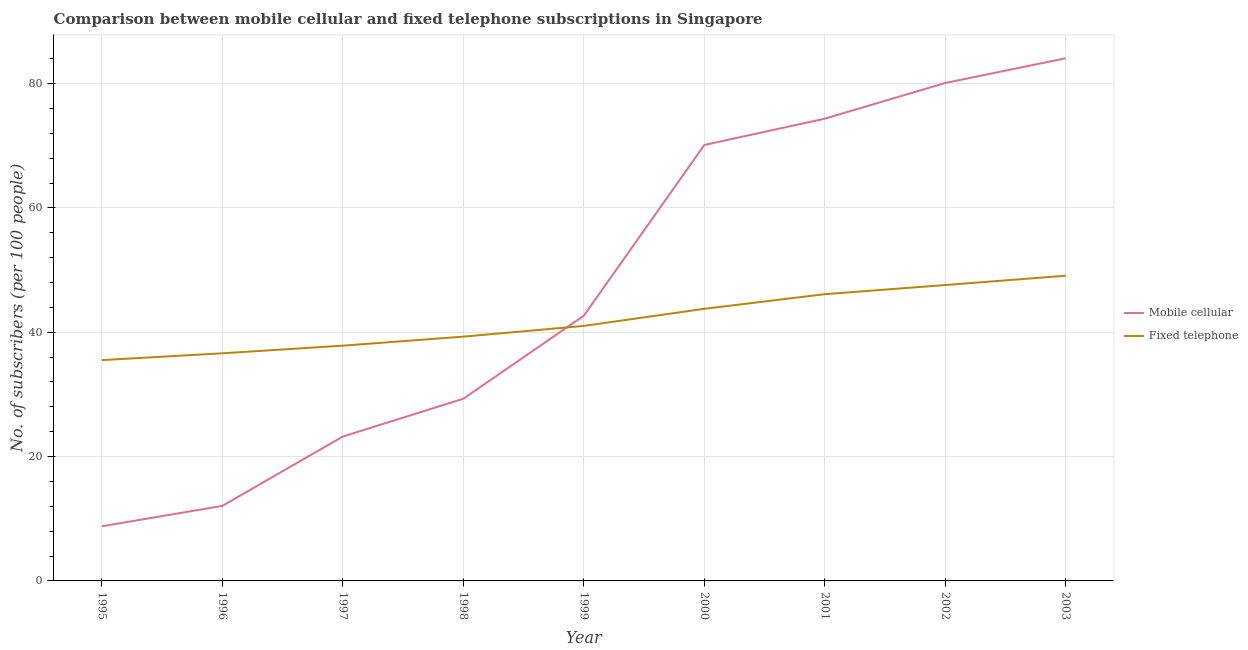How many different coloured lines are there?
Give a very brief answer. 2. Does the line corresponding to number of fixed telephone subscribers intersect with the line corresponding to number of mobile cellular subscribers?
Give a very brief answer. Yes. Is the number of lines equal to the number of legend labels?
Keep it short and to the point. Yes. What is the number of fixed telephone subscribers in 2001?
Offer a terse response. 46.12. Across all years, what is the maximum number of mobile cellular subscribers?
Keep it short and to the point. 84.07. Across all years, what is the minimum number of mobile cellular subscribers?
Your answer should be very brief. 8.79. In which year was the number of fixed telephone subscribers minimum?
Ensure brevity in your answer.  1995. What is the total number of mobile cellular subscribers in the graph?
Your answer should be very brief. 424.7. What is the difference between the number of fixed telephone subscribers in 1995 and that in 1999?
Give a very brief answer. -5.5. What is the difference between the number of mobile cellular subscribers in 2001 and the number of fixed telephone subscribers in 1995?
Make the answer very short. 38.84. What is the average number of fixed telephone subscribers per year?
Provide a short and direct response. 41.87. In the year 2000, what is the difference between the number of fixed telephone subscribers and number of mobile cellular subscribers?
Provide a short and direct response. -26.35. What is the ratio of the number of fixed telephone subscribers in 1996 to that in 2003?
Your response must be concise. 0.75. Is the number of fixed telephone subscribers in 1999 less than that in 2000?
Provide a short and direct response. Yes. What is the difference between the highest and the second highest number of mobile cellular subscribers?
Keep it short and to the point. 3.97. What is the difference between the highest and the lowest number of mobile cellular subscribers?
Offer a terse response. 75.28. In how many years, is the number of fixed telephone subscribers greater than the average number of fixed telephone subscribers taken over all years?
Make the answer very short. 4. Does the number of mobile cellular subscribers monotonically increase over the years?
Provide a succinct answer. Yes. Is the number of fixed telephone subscribers strictly greater than the number of mobile cellular subscribers over the years?
Your response must be concise. No. How many years are there in the graph?
Offer a very short reply. 9. What is the difference between two consecutive major ticks on the Y-axis?
Your response must be concise. 20. Does the graph contain any zero values?
Keep it short and to the point. No. How many legend labels are there?
Your answer should be very brief. 2. What is the title of the graph?
Your answer should be compact. Comparison between mobile cellular and fixed telephone subscriptions in Singapore. What is the label or title of the Y-axis?
Your response must be concise. No. of subscribers (per 100 people). What is the No. of subscribers (per 100 people) in Mobile cellular in 1995?
Make the answer very short. 8.79. What is the No. of subscribers (per 100 people) of Fixed telephone in 1995?
Your answer should be compact. 35.52. What is the No. of subscribers (per 100 people) in Mobile cellular in 1996?
Ensure brevity in your answer.  12.07. What is the No. of subscribers (per 100 people) of Fixed telephone in 1996?
Offer a terse response. 36.61. What is the No. of subscribers (per 100 people) in Mobile cellular in 1997?
Offer a very short reply. 23.23. What is the No. of subscribers (per 100 people) in Fixed telephone in 1997?
Your answer should be very brief. 37.84. What is the No. of subscribers (per 100 people) of Mobile cellular in 1998?
Offer a very short reply. 29.31. What is the No. of subscribers (per 100 people) of Fixed telephone in 1998?
Your answer should be very brief. 39.29. What is the No. of subscribers (per 100 people) in Mobile cellular in 1999?
Provide a succinct answer. 42.66. What is the No. of subscribers (per 100 people) of Fixed telephone in 1999?
Give a very brief answer. 41.02. What is the No. of subscribers (per 100 people) in Mobile cellular in 2000?
Make the answer very short. 70.12. What is the No. of subscribers (per 100 people) in Fixed telephone in 2000?
Offer a very short reply. 43.77. What is the No. of subscribers (per 100 people) of Mobile cellular in 2001?
Ensure brevity in your answer.  74.36. What is the No. of subscribers (per 100 people) of Fixed telephone in 2001?
Give a very brief answer. 46.12. What is the No. of subscribers (per 100 people) in Mobile cellular in 2002?
Your response must be concise. 80.1. What is the No. of subscribers (per 100 people) in Fixed telephone in 2002?
Your answer should be very brief. 47.59. What is the No. of subscribers (per 100 people) of Mobile cellular in 2003?
Keep it short and to the point. 84.07. What is the No. of subscribers (per 100 people) in Fixed telephone in 2003?
Your response must be concise. 49.09. Across all years, what is the maximum No. of subscribers (per 100 people) of Mobile cellular?
Provide a succinct answer. 84.07. Across all years, what is the maximum No. of subscribers (per 100 people) of Fixed telephone?
Make the answer very short. 49.09. Across all years, what is the minimum No. of subscribers (per 100 people) in Mobile cellular?
Make the answer very short. 8.79. Across all years, what is the minimum No. of subscribers (per 100 people) in Fixed telephone?
Offer a very short reply. 35.52. What is the total No. of subscribers (per 100 people) in Mobile cellular in the graph?
Give a very brief answer. 424.7. What is the total No. of subscribers (per 100 people) in Fixed telephone in the graph?
Your response must be concise. 376.87. What is the difference between the No. of subscribers (per 100 people) in Mobile cellular in 1995 and that in 1996?
Your answer should be compact. -3.29. What is the difference between the No. of subscribers (per 100 people) in Fixed telephone in 1995 and that in 1996?
Your answer should be compact. -1.1. What is the difference between the No. of subscribers (per 100 people) of Mobile cellular in 1995 and that in 1997?
Provide a succinct answer. -14.44. What is the difference between the No. of subscribers (per 100 people) of Fixed telephone in 1995 and that in 1997?
Offer a very short reply. -2.33. What is the difference between the No. of subscribers (per 100 people) of Mobile cellular in 1995 and that in 1998?
Your answer should be very brief. -20.52. What is the difference between the No. of subscribers (per 100 people) in Fixed telephone in 1995 and that in 1998?
Offer a terse response. -3.78. What is the difference between the No. of subscribers (per 100 people) of Mobile cellular in 1995 and that in 1999?
Your answer should be compact. -33.88. What is the difference between the No. of subscribers (per 100 people) of Fixed telephone in 1995 and that in 1999?
Make the answer very short. -5.5. What is the difference between the No. of subscribers (per 100 people) in Mobile cellular in 1995 and that in 2000?
Your response must be concise. -61.33. What is the difference between the No. of subscribers (per 100 people) in Fixed telephone in 1995 and that in 2000?
Provide a short and direct response. -8.25. What is the difference between the No. of subscribers (per 100 people) in Mobile cellular in 1995 and that in 2001?
Provide a succinct answer. -65.57. What is the difference between the No. of subscribers (per 100 people) of Fixed telephone in 1995 and that in 2001?
Your answer should be compact. -10.61. What is the difference between the No. of subscribers (per 100 people) in Mobile cellular in 1995 and that in 2002?
Offer a terse response. -71.31. What is the difference between the No. of subscribers (per 100 people) of Fixed telephone in 1995 and that in 2002?
Your answer should be very brief. -12.08. What is the difference between the No. of subscribers (per 100 people) in Mobile cellular in 1995 and that in 2003?
Provide a short and direct response. -75.28. What is the difference between the No. of subscribers (per 100 people) of Fixed telephone in 1995 and that in 2003?
Provide a short and direct response. -13.57. What is the difference between the No. of subscribers (per 100 people) of Mobile cellular in 1996 and that in 1997?
Make the answer very short. -11.16. What is the difference between the No. of subscribers (per 100 people) in Fixed telephone in 1996 and that in 1997?
Your response must be concise. -1.23. What is the difference between the No. of subscribers (per 100 people) in Mobile cellular in 1996 and that in 1998?
Your answer should be compact. -17.23. What is the difference between the No. of subscribers (per 100 people) of Fixed telephone in 1996 and that in 1998?
Ensure brevity in your answer.  -2.68. What is the difference between the No. of subscribers (per 100 people) of Mobile cellular in 1996 and that in 1999?
Your answer should be very brief. -30.59. What is the difference between the No. of subscribers (per 100 people) of Fixed telephone in 1996 and that in 1999?
Give a very brief answer. -4.41. What is the difference between the No. of subscribers (per 100 people) of Mobile cellular in 1996 and that in 2000?
Provide a succinct answer. -58.05. What is the difference between the No. of subscribers (per 100 people) in Fixed telephone in 1996 and that in 2000?
Your answer should be very brief. -7.16. What is the difference between the No. of subscribers (per 100 people) in Mobile cellular in 1996 and that in 2001?
Give a very brief answer. -62.28. What is the difference between the No. of subscribers (per 100 people) of Fixed telephone in 1996 and that in 2001?
Provide a succinct answer. -9.51. What is the difference between the No. of subscribers (per 100 people) of Mobile cellular in 1996 and that in 2002?
Give a very brief answer. -68.02. What is the difference between the No. of subscribers (per 100 people) of Fixed telephone in 1996 and that in 2002?
Provide a short and direct response. -10.98. What is the difference between the No. of subscribers (per 100 people) in Mobile cellular in 1996 and that in 2003?
Give a very brief answer. -72. What is the difference between the No. of subscribers (per 100 people) in Fixed telephone in 1996 and that in 2003?
Your answer should be compact. -12.48. What is the difference between the No. of subscribers (per 100 people) in Mobile cellular in 1997 and that in 1998?
Provide a short and direct response. -6.08. What is the difference between the No. of subscribers (per 100 people) in Fixed telephone in 1997 and that in 1998?
Make the answer very short. -1.45. What is the difference between the No. of subscribers (per 100 people) of Mobile cellular in 1997 and that in 1999?
Your answer should be compact. -19.43. What is the difference between the No. of subscribers (per 100 people) of Fixed telephone in 1997 and that in 1999?
Provide a succinct answer. -3.18. What is the difference between the No. of subscribers (per 100 people) of Mobile cellular in 1997 and that in 2000?
Give a very brief answer. -46.89. What is the difference between the No. of subscribers (per 100 people) of Fixed telephone in 1997 and that in 2000?
Your answer should be very brief. -5.93. What is the difference between the No. of subscribers (per 100 people) of Mobile cellular in 1997 and that in 2001?
Offer a terse response. -51.13. What is the difference between the No. of subscribers (per 100 people) in Fixed telephone in 1997 and that in 2001?
Offer a very short reply. -8.28. What is the difference between the No. of subscribers (per 100 people) of Mobile cellular in 1997 and that in 2002?
Keep it short and to the point. -56.87. What is the difference between the No. of subscribers (per 100 people) in Fixed telephone in 1997 and that in 2002?
Your answer should be very brief. -9.75. What is the difference between the No. of subscribers (per 100 people) of Mobile cellular in 1997 and that in 2003?
Offer a terse response. -60.84. What is the difference between the No. of subscribers (per 100 people) of Fixed telephone in 1997 and that in 2003?
Offer a very short reply. -11.25. What is the difference between the No. of subscribers (per 100 people) in Mobile cellular in 1998 and that in 1999?
Offer a terse response. -13.36. What is the difference between the No. of subscribers (per 100 people) in Fixed telephone in 1998 and that in 1999?
Provide a short and direct response. -1.73. What is the difference between the No. of subscribers (per 100 people) in Mobile cellular in 1998 and that in 2000?
Your answer should be compact. -40.81. What is the difference between the No. of subscribers (per 100 people) in Fixed telephone in 1998 and that in 2000?
Your answer should be compact. -4.48. What is the difference between the No. of subscribers (per 100 people) of Mobile cellular in 1998 and that in 2001?
Ensure brevity in your answer.  -45.05. What is the difference between the No. of subscribers (per 100 people) of Fixed telephone in 1998 and that in 2001?
Offer a terse response. -6.83. What is the difference between the No. of subscribers (per 100 people) of Mobile cellular in 1998 and that in 2002?
Offer a very short reply. -50.79. What is the difference between the No. of subscribers (per 100 people) of Mobile cellular in 1998 and that in 2003?
Keep it short and to the point. -54.77. What is the difference between the No. of subscribers (per 100 people) in Fixed telephone in 1998 and that in 2003?
Provide a succinct answer. -9.8. What is the difference between the No. of subscribers (per 100 people) of Mobile cellular in 1999 and that in 2000?
Ensure brevity in your answer.  -27.46. What is the difference between the No. of subscribers (per 100 people) in Fixed telephone in 1999 and that in 2000?
Provide a short and direct response. -2.75. What is the difference between the No. of subscribers (per 100 people) in Mobile cellular in 1999 and that in 2001?
Provide a succinct answer. -31.7. What is the difference between the No. of subscribers (per 100 people) of Fixed telephone in 1999 and that in 2001?
Provide a succinct answer. -5.1. What is the difference between the No. of subscribers (per 100 people) in Mobile cellular in 1999 and that in 2002?
Offer a terse response. -37.44. What is the difference between the No. of subscribers (per 100 people) of Fixed telephone in 1999 and that in 2002?
Your answer should be compact. -6.57. What is the difference between the No. of subscribers (per 100 people) in Mobile cellular in 1999 and that in 2003?
Give a very brief answer. -41.41. What is the difference between the No. of subscribers (per 100 people) in Fixed telephone in 1999 and that in 2003?
Make the answer very short. -8.07. What is the difference between the No. of subscribers (per 100 people) of Mobile cellular in 2000 and that in 2001?
Give a very brief answer. -4.24. What is the difference between the No. of subscribers (per 100 people) in Fixed telephone in 2000 and that in 2001?
Your answer should be very brief. -2.35. What is the difference between the No. of subscribers (per 100 people) in Mobile cellular in 2000 and that in 2002?
Provide a short and direct response. -9.98. What is the difference between the No. of subscribers (per 100 people) of Fixed telephone in 2000 and that in 2002?
Make the answer very short. -3.82. What is the difference between the No. of subscribers (per 100 people) of Mobile cellular in 2000 and that in 2003?
Give a very brief answer. -13.95. What is the difference between the No. of subscribers (per 100 people) of Fixed telephone in 2000 and that in 2003?
Your response must be concise. -5.32. What is the difference between the No. of subscribers (per 100 people) of Mobile cellular in 2001 and that in 2002?
Your answer should be very brief. -5.74. What is the difference between the No. of subscribers (per 100 people) of Fixed telephone in 2001 and that in 2002?
Give a very brief answer. -1.47. What is the difference between the No. of subscribers (per 100 people) in Mobile cellular in 2001 and that in 2003?
Your response must be concise. -9.71. What is the difference between the No. of subscribers (per 100 people) in Fixed telephone in 2001 and that in 2003?
Offer a very short reply. -2.97. What is the difference between the No. of subscribers (per 100 people) in Mobile cellular in 2002 and that in 2003?
Offer a terse response. -3.97. What is the difference between the No. of subscribers (per 100 people) of Fixed telephone in 2002 and that in 2003?
Give a very brief answer. -1.5. What is the difference between the No. of subscribers (per 100 people) of Mobile cellular in 1995 and the No. of subscribers (per 100 people) of Fixed telephone in 1996?
Provide a succinct answer. -27.83. What is the difference between the No. of subscribers (per 100 people) of Mobile cellular in 1995 and the No. of subscribers (per 100 people) of Fixed telephone in 1997?
Offer a very short reply. -29.06. What is the difference between the No. of subscribers (per 100 people) of Mobile cellular in 1995 and the No. of subscribers (per 100 people) of Fixed telephone in 1998?
Offer a terse response. -30.51. What is the difference between the No. of subscribers (per 100 people) of Mobile cellular in 1995 and the No. of subscribers (per 100 people) of Fixed telephone in 1999?
Offer a terse response. -32.23. What is the difference between the No. of subscribers (per 100 people) of Mobile cellular in 1995 and the No. of subscribers (per 100 people) of Fixed telephone in 2000?
Your answer should be very brief. -34.99. What is the difference between the No. of subscribers (per 100 people) in Mobile cellular in 1995 and the No. of subscribers (per 100 people) in Fixed telephone in 2001?
Keep it short and to the point. -37.34. What is the difference between the No. of subscribers (per 100 people) in Mobile cellular in 1995 and the No. of subscribers (per 100 people) in Fixed telephone in 2002?
Offer a very short reply. -38.81. What is the difference between the No. of subscribers (per 100 people) of Mobile cellular in 1995 and the No. of subscribers (per 100 people) of Fixed telephone in 2003?
Provide a short and direct response. -40.31. What is the difference between the No. of subscribers (per 100 people) of Mobile cellular in 1996 and the No. of subscribers (per 100 people) of Fixed telephone in 1997?
Your answer should be compact. -25.77. What is the difference between the No. of subscribers (per 100 people) of Mobile cellular in 1996 and the No. of subscribers (per 100 people) of Fixed telephone in 1998?
Your answer should be compact. -27.22. What is the difference between the No. of subscribers (per 100 people) in Mobile cellular in 1996 and the No. of subscribers (per 100 people) in Fixed telephone in 1999?
Give a very brief answer. -28.95. What is the difference between the No. of subscribers (per 100 people) in Mobile cellular in 1996 and the No. of subscribers (per 100 people) in Fixed telephone in 2000?
Your response must be concise. -31.7. What is the difference between the No. of subscribers (per 100 people) of Mobile cellular in 1996 and the No. of subscribers (per 100 people) of Fixed telephone in 2001?
Provide a short and direct response. -34.05. What is the difference between the No. of subscribers (per 100 people) of Mobile cellular in 1996 and the No. of subscribers (per 100 people) of Fixed telephone in 2002?
Make the answer very short. -35.52. What is the difference between the No. of subscribers (per 100 people) in Mobile cellular in 1996 and the No. of subscribers (per 100 people) in Fixed telephone in 2003?
Offer a very short reply. -37.02. What is the difference between the No. of subscribers (per 100 people) of Mobile cellular in 1997 and the No. of subscribers (per 100 people) of Fixed telephone in 1998?
Provide a succinct answer. -16.07. What is the difference between the No. of subscribers (per 100 people) of Mobile cellular in 1997 and the No. of subscribers (per 100 people) of Fixed telephone in 1999?
Give a very brief answer. -17.79. What is the difference between the No. of subscribers (per 100 people) in Mobile cellular in 1997 and the No. of subscribers (per 100 people) in Fixed telephone in 2000?
Make the answer very short. -20.54. What is the difference between the No. of subscribers (per 100 people) in Mobile cellular in 1997 and the No. of subscribers (per 100 people) in Fixed telephone in 2001?
Offer a terse response. -22.89. What is the difference between the No. of subscribers (per 100 people) in Mobile cellular in 1997 and the No. of subscribers (per 100 people) in Fixed telephone in 2002?
Offer a terse response. -24.36. What is the difference between the No. of subscribers (per 100 people) of Mobile cellular in 1997 and the No. of subscribers (per 100 people) of Fixed telephone in 2003?
Make the answer very short. -25.86. What is the difference between the No. of subscribers (per 100 people) in Mobile cellular in 1998 and the No. of subscribers (per 100 people) in Fixed telephone in 1999?
Provide a short and direct response. -11.72. What is the difference between the No. of subscribers (per 100 people) in Mobile cellular in 1998 and the No. of subscribers (per 100 people) in Fixed telephone in 2000?
Provide a short and direct response. -14.47. What is the difference between the No. of subscribers (per 100 people) of Mobile cellular in 1998 and the No. of subscribers (per 100 people) of Fixed telephone in 2001?
Your answer should be very brief. -16.82. What is the difference between the No. of subscribers (per 100 people) of Mobile cellular in 1998 and the No. of subscribers (per 100 people) of Fixed telephone in 2002?
Provide a succinct answer. -18.29. What is the difference between the No. of subscribers (per 100 people) of Mobile cellular in 1998 and the No. of subscribers (per 100 people) of Fixed telephone in 2003?
Ensure brevity in your answer.  -19.79. What is the difference between the No. of subscribers (per 100 people) of Mobile cellular in 1999 and the No. of subscribers (per 100 people) of Fixed telephone in 2000?
Provide a succinct answer. -1.11. What is the difference between the No. of subscribers (per 100 people) in Mobile cellular in 1999 and the No. of subscribers (per 100 people) in Fixed telephone in 2001?
Offer a very short reply. -3.46. What is the difference between the No. of subscribers (per 100 people) of Mobile cellular in 1999 and the No. of subscribers (per 100 people) of Fixed telephone in 2002?
Provide a short and direct response. -4.93. What is the difference between the No. of subscribers (per 100 people) in Mobile cellular in 1999 and the No. of subscribers (per 100 people) in Fixed telephone in 2003?
Your answer should be very brief. -6.43. What is the difference between the No. of subscribers (per 100 people) of Mobile cellular in 2000 and the No. of subscribers (per 100 people) of Fixed telephone in 2001?
Ensure brevity in your answer.  24. What is the difference between the No. of subscribers (per 100 people) in Mobile cellular in 2000 and the No. of subscribers (per 100 people) in Fixed telephone in 2002?
Keep it short and to the point. 22.52. What is the difference between the No. of subscribers (per 100 people) of Mobile cellular in 2000 and the No. of subscribers (per 100 people) of Fixed telephone in 2003?
Ensure brevity in your answer.  21.03. What is the difference between the No. of subscribers (per 100 people) in Mobile cellular in 2001 and the No. of subscribers (per 100 people) in Fixed telephone in 2002?
Make the answer very short. 26.76. What is the difference between the No. of subscribers (per 100 people) of Mobile cellular in 2001 and the No. of subscribers (per 100 people) of Fixed telephone in 2003?
Provide a succinct answer. 25.27. What is the difference between the No. of subscribers (per 100 people) in Mobile cellular in 2002 and the No. of subscribers (per 100 people) in Fixed telephone in 2003?
Your response must be concise. 31. What is the average No. of subscribers (per 100 people) in Mobile cellular per year?
Offer a very short reply. 47.19. What is the average No. of subscribers (per 100 people) of Fixed telephone per year?
Your answer should be compact. 41.87. In the year 1995, what is the difference between the No. of subscribers (per 100 people) in Mobile cellular and No. of subscribers (per 100 people) in Fixed telephone?
Your response must be concise. -26.73. In the year 1996, what is the difference between the No. of subscribers (per 100 people) of Mobile cellular and No. of subscribers (per 100 people) of Fixed telephone?
Your answer should be compact. -24.54. In the year 1997, what is the difference between the No. of subscribers (per 100 people) of Mobile cellular and No. of subscribers (per 100 people) of Fixed telephone?
Give a very brief answer. -14.62. In the year 1998, what is the difference between the No. of subscribers (per 100 people) in Mobile cellular and No. of subscribers (per 100 people) in Fixed telephone?
Your answer should be very brief. -9.99. In the year 1999, what is the difference between the No. of subscribers (per 100 people) in Mobile cellular and No. of subscribers (per 100 people) in Fixed telephone?
Offer a very short reply. 1.64. In the year 2000, what is the difference between the No. of subscribers (per 100 people) of Mobile cellular and No. of subscribers (per 100 people) of Fixed telephone?
Provide a succinct answer. 26.35. In the year 2001, what is the difference between the No. of subscribers (per 100 people) of Mobile cellular and No. of subscribers (per 100 people) of Fixed telephone?
Keep it short and to the point. 28.23. In the year 2002, what is the difference between the No. of subscribers (per 100 people) of Mobile cellular and No. of subscribers (per 100 people) of Fixed telephone?
Offer a very short reply. 32.5. In the year 2003, what is the difference between the No. of subscribers (per 100 people) in Mobile cellular and No. of subscribers (per 100 people) in Fixed telephone?
Your answer should be very brief. 34.98. What is the ratio of the No. of subscribers (per 100 people) of Mobile cellular in 1995 to that in 1996?
Ensure brevity in your answer.  0.73. What is the ratio of the No. of subscribers (per 100 people) in Fixed telephone in 1995 to that in 1996?
Make the answer very short. 0.97. What is the ratio of the No. of subscribers (per 100 people) of Mobile cellular in 1995 to that in 1997?
Offer a very short reply. 0.38. What is the ratio of the No. of subscribers (per 100 people) in Fixed telephone in 1995 to that in 1997?
Provide a short and direct response. 0.94. What is the ratio of the No. of subscribers (per 100 people) of Mobile cellular in 1995 to that in 1998?
Provide a short and direct response. 0.3. What is the ratio of the No. of subscribers (per 100 people) in Fixed telephone in 1995 to that in 1998?
Your answer should be very brief. 0.9. What is the ratio of the No. of subscribers (per 100 people) of Mobile cellular in 1995 to that in 1999?
Provide a succinct answer. 0.21. What is the ratio of the No. of subscribers (per 100 people) in Fixed telephone in 1995 to that in 1999?
Your answer should be very brief. 0.87. What is the ratio of the No. of subscribers (per 100 people) in Mobile cellular in 1995 to that in 2000?
Offer a very short reply. 0.13. What is the ratio of the No. of subscribers (per 100 people) of Fixed telephone in 1995 to that in 2000?
Give a very brief answer. 0.81. What is the ratio of the No. of subscribers (per 100 people) in Mobile cellular in 1995 to that in 2001?
Make the answer very short. 0.12. What is the ratio of the No. of subscribers (per 100 people) of Fixed telephone in 1995 to that in 2001?
Ensure brevity in your answer.  0.77. What is the ratio of the No. of subscribers (per 100 people) of Mobile cellular in 1995 to that in 2002?
Keep it short and to the point. 0.11. What is the ratio of the No. of subscribers (per 100 people) in Fixed telephone in 1995 to that in 2002?
Your answer should be compact. 0.75. What is the ratio of the No. of subscribers (per 100 people) in Mobile cellular in 1995 to that in 2003?
Your answer should be very brief. 0.1. What is the ratio of the No. of subscribers (per 100 people) in Fixed telephone in 1995 to that in 2003?
Offer a very short reply. 0.72. What is the ratio of the No. of subscribers (per 100 people) in Mobile cellular in 1996 to that in 1997?
Your answer should be compact. 0.52. What is the ratio of the No. of subscribers (per 100 people) of Fixed telephone in 1996 to that in 1997?
Provide a succinct answer. 0.97. What is the ratio of the No. of subscribers (per 100 people) in Mobile cellular in 1996 to that in 1998?
Provide a succinct answer. 0.41. What is the ratio of the No. of subscribers (per 100 people) of Fixed telephone in 1996 to that in 1998?
Ensure brevity in your answer.  0.93. What is the ratio of the No. of subscribers (per 100 people) of Mobile cellular in 1996 to that in 1999?
Offer a terse response. 0.28. What is the ratio of the No. of subscribers (per 100 people) in Fixed telephone in 1996 to that in 1999?
Your answer should be very brief. 0.89. What is the ratio of the No. of subscribers (per 100 people) of Mobile cellular in 1996 to that in 2000?
Your answer should be very brief. 0.17. What is the ratio of the No. of subscribers (per 100 people) in Fixed telephone in 1996 to that in 2000?
Your response must be concise. 0.84. What is the ratio of the No. of subscribers (per 100 people) of Mobile cellular in 1996 to that in 2001?
Your answer should be very brief. 0.16. What is the ratio of the No. of subscribers (per 100 people) in Fixed telephone in 1996 to that in 2001?
Provide a succinct answer. 0.79. What is the ratio of the No. of subscribers (per 100 people) in Mobile cellular in 1996 to that in 2002?
Provide a short and direct response. 0.15. What is the ratio of the No. of subscribers (per 100 people) in Fixed telephone in 1996 to that in 2002?
Your answer should be very brief. 0.77. What is the ratio of the No. of subscribers (per 100 people) in Mobile cellular in 1996 to that in 2003?
Keep it short and to the point. 0.14. What is the ratio of the No. of subscribers (per 100 people) in Fixed telephone in 1996 to that in 2003?
Give a very brief answer. 0.75. What is the ratio of the No. of subscribers (per 100 people) of Mobile cellular in 1997 to that in 1998?
Your response must be concise. 0.79. What is the ratio of the No. of subscribers (per 100 people) in Fixed telephone in 1997 to that in 1998?
Your answer should be very brief. 0.96. What is the ratio of the No. of subscribers (per 100 people) of Mobile cellular in 1997 to that in 1999?
Keep it short and to the point. 0.54. What is the ratio of the No. of subscribers (per 100 people) in Fixed telephone in 1997 to that in 1999?
Your response must be concise. 0.92. What is the ratio of the No. of subscribers (per 100 people) of Mobile cellular in 1997 to that in 2000?
Keep it short and to the point. 0.33. What is the ratio of the No. of subscribers (per 100 people) of Fixed telephone in 1997 to that in 2000?
Provide a succinct answer. 0.86. What is the ratio of the No. of subscribers (per 100 people) in Mobile cellular in 1997 to that in 2001?
Keep it short and to the point. 0.31. What is the ratio of the No. of subscribers (per 100 people) in Fixed telephone in 1997 to that in 2001?
Offer a terse response. 0.82. What is the ratio of the No. of subscribers (per 100 people) in Mobile cellular in 1997 to that in 2002?
Offer a terse response. 0.29. What is the ratio of the No. of subscribers (per 100 people) of Fixed telephone in 1997 to that in 2002?
Your answer should be very brief. 0.8. What is the ratio of the No. of subscribers (per 100 people) of Mobile cellular in 1997 to that in 2003?
Your answer should be very brief. 0.28. What is the ratio of the No. of subscribers (per 100 people) in Fixed telephone in 1997 to that in 2003?
Your answer should be very brief. 0.77. What is the ratio of the No. of subscribers (per 100 people) of Mobile cellular in 1998 to that in 1999?
Keep it short and to the point. 0.69. What is the ratio of the No. of subscribers (per 100 people) of Fixed telephone in 1998 to that in 1999?
Your response must be concise. 0.96. What is the ratio of the No. of subscribers (per 100 people) of Mobile cellular in 1998 to that in 2000?
Ensure brevity in your answer.  0.42. What is the ratio of the No. of subscribers (per 100 people) of Fixed telephone in 1998 to that in 2000?
Ensure brevity in your answer.  0.9. What is the ratio of the No. of subscribers (per 100 people) in Mobile cellular in 1998 to that in 2001?
Give a very brief answer. 0.39. What is the ratio of the No. of subscribers (per 100 people) in Fixed telephone in 1998 to that in 2001?
Provide a short and direct response. 0.85. What is the ratio of the No. of subscribers (per 100 people) in Mobile cellular in 1998 to that in 2002?
Give a very brief answer. 0.37. What is the ratio of the No. of subscribers (per 100 people) in Fixed telephone in 1998 to that in 2002?
Offer a very short reply. 0.83. What is the ratio of the No. of subscribers (per 100 people) in Mobile cellular in 1998 to that in 2003?
Ensure brevity in your answer.  0.35. What is the ratio of the No. of subscribers (per 100 people) in Fixed telephone in 1998 to that in 2003?
Your answer should be compact. 0.8. What is the ratio of the No. of subscribers (per 100 people) in Mobile cellular in 1999 to that in 2000?
Offer a terse response. 0.61. What is the ratio of the No. of subscribers (per 100 people) of Fixed telephone in 1999 to that in 2000?
Your answer should be very brief. 0.94. What is the ratio of the No. of subscribers (per 100 people) of Mobile cellular in 1999 to that in 2001?
Provide a succinct answer. 0.57. What is the ratio of the No. of subscribers (per 100 people) of Fixed telephone in 1999 to that in 2001?
Give a very brief answer. 0.89. What is the ratio of the No. of subscribers (per 100 people) of Mobile cellular in 1999 to that in 2002?
Provide a short and direct response. 0.53. What is the ratio of the No. of subscribers (per 100 people) in Fixed telephone in 1999 to that in 2002?
Offer a terse response. 0.86. What is the ratio of the No. of subscribers (per 100 people) of Mobile cellular in 1999 to that in 2003?
Give a very brief answer. 0.51. What is the ratio of the No. of subscribers (per 100 people) in Fixed telephone in 1999 to that in 2003?
Provide a short and direct response. 0.84. What is the ratio of the No. of subscribers (per 100 people) in Mobile cellular in 2000 to that in 2001?
Keep it short and to the point. 0.94. What is the ratio of the No. of subscribers (per 100 people) in Fixed telephone in 2000 to that in 2001?
Provide a short and direct response. 0.95. What is the ratio of the No. of subscribers (per 100 people) of Mobile cellular in 2000 to that in 2002?
Your answer should be compact. 0.88. What is the ratio of the No. of subscribers (per 100 people) of Fixed telephone in 2000 to that in 2002?
Your answer should be very brief. 0.92. What is the ratio of the No. of subscribers (per 100 people) of Mobile cellular in 2000 to that in 2003?
Keep it short and to the point. 0.83. What is the ratio of the No. of subscribers (per 100 people) in Fixed telephone in 2000 to that in 2003?
Offer a terse response. 0.89. What is the ratio of the No. of subscribers (per 100 people) of Mobile cellular in 2001 to that in 2002?
Your response must be concise. 0.93. What is the ratio of the No. of subscribers (per 100 people) of Fixed telephone in 2001 to that in 2002?
Give a very brief answer. 0.97. What is the ratio of the No. of subscribers (per 100 people) in Mobile cellular in 2001 to that in 2003?
Make the answer very short. 0.88. What is the ratio of the No. of subscribers (per 100 people) in Fixed telephone in 2001 to that in 2003?
Your answer should be very brief. 0.94. What is the ratio of the No. of subscribers (per 100 people) in Mobile cellular in 2002 to that in 2003?
Offer a terse response. 0.95. What is the ratio of the No. of subscribers (per 100 people) of Fixed telephone in 2002 to that in 2003?
Your answer should be compact. 0.97. What is the difference between the highest and the second highest No. of subscribers (per 100 people) in Mobile cellular?
Make the answer very short. 3.97. What is the difference between the highest and the second highest No. of subscribers (per 100 people) of Fixed telephone?
Your answer should be compact. 1.5. What is the difference between the highest and the lowest No. of subscribers (per 100 people) of Mobile cellular?
Your answer should be compact. 75.28. What is the difference between the highest and the lowest No. of subscribers (per 100 people) of Fixed telephone?
Give a very brief answer. 13.57. 